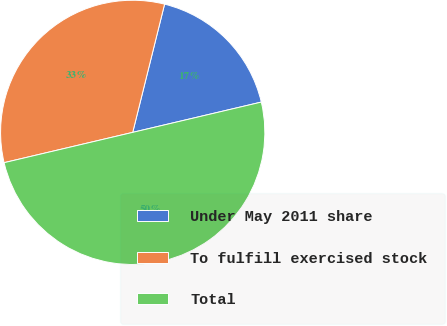Convert chart. <chart><loc_0><loc_0><loc_500><loc_500><pie_chart><fcel>Under May 2011 share<fcel>To fulfill exercised stock<fcel>Total<nl><fcel>17.44%<fcel>32.56%<fcel>50.0%<nl></chart> 